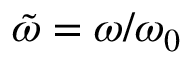Convert formula to latex. <formula><loc_0><loc_0><loc_500><loc_500>{ \tilde { \omega } } = \omega / \omega _ { 0 }</formula> 